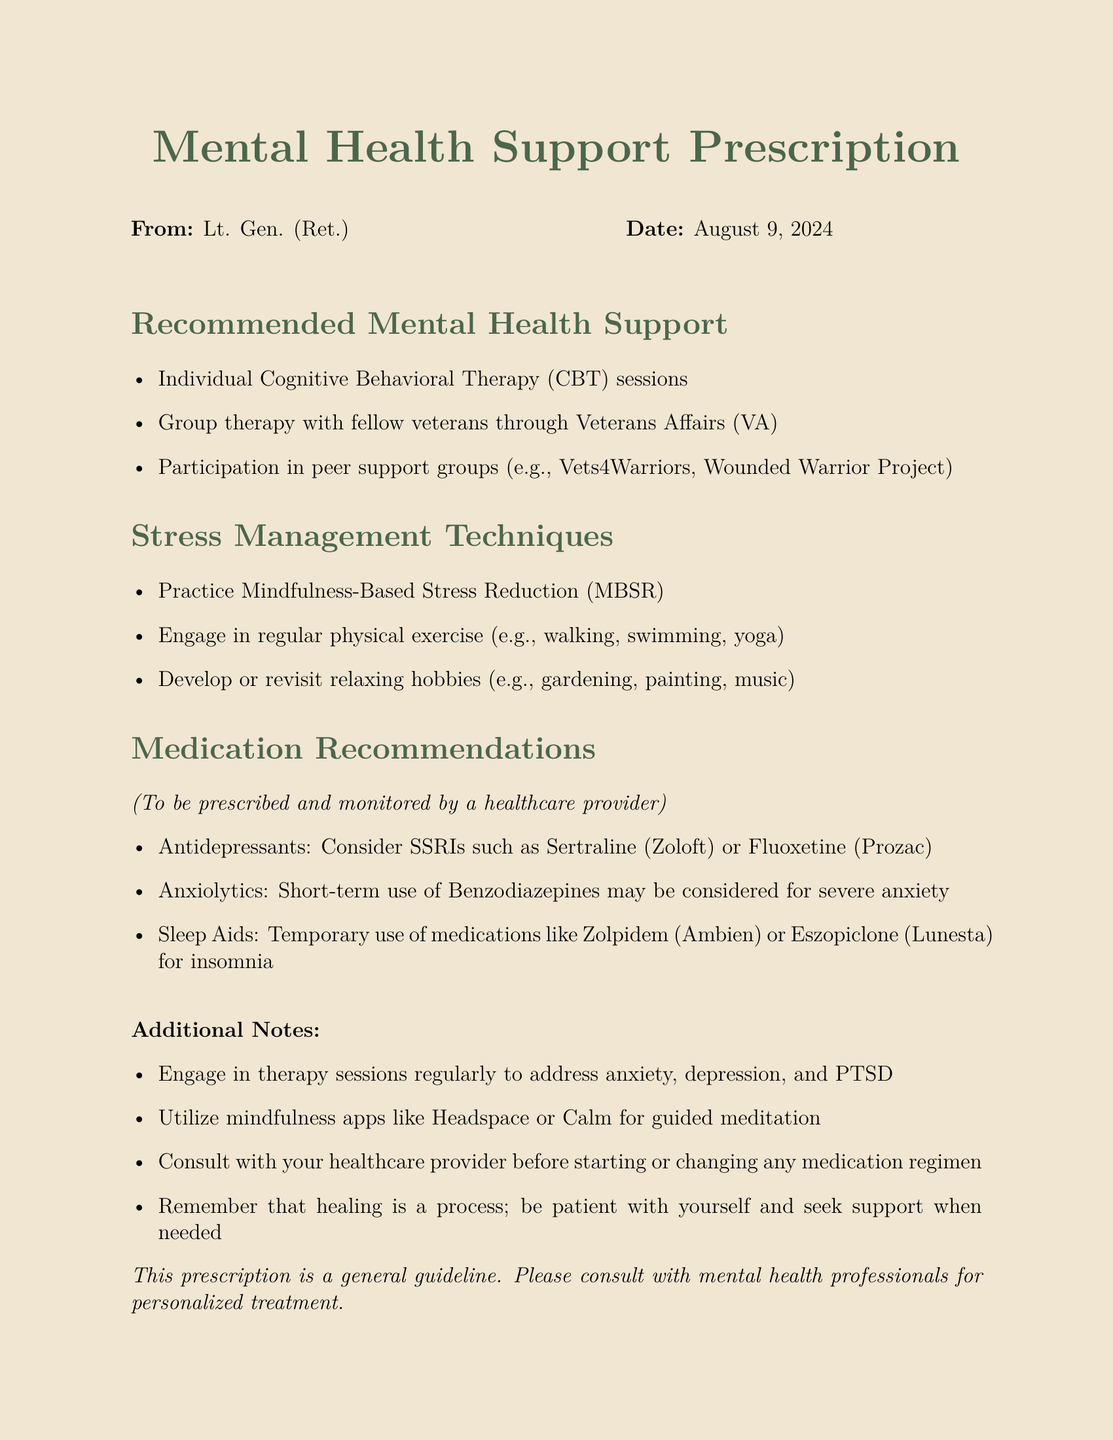What are the recommended individual therapy sessions? The document mentions Cognitive Behavioral Therapy (CBT) sessions as the recommended individual therapy.
Answer: Cognitive Behavioral Therapy (CBT) sessions What is one of the relaxation hobbies suggested? The document lists various relaxing hobbies and one mentioned is gardening.
Answer: gardening Which medications are suggested as antidepressants? The document specifies SSRIs such as Sertraline (Zoloft) or Fluoxetine (Prozac) as antidepressants.
Answer: Sertraline (Zoloft) or Fluoxetine (Prozac) What type of therapy is advised for veterans? The document recommends group therapy with fellow veterans through Veterans Affairs (VA).
Answer: group therapy What mindfulness technique should be practiced? The document recommends practicing Mindfulness-Based Stress Reduction (MBSR) as a technique.
Answer: Mindfulness-Based Stress Reduction (MBSR) Which apps are suggested for mindfulness? The document suggests using mindfulness apps like Headspace or Calm for guided meditation.
Answer: Headspace or Calm What condition do the medications aim to address? The medications mentioned are aimed at conditions like anxiety, depression, and insomnia as specified in the document.
Answer: anxiety, depression, and insomnia How should one approach the use of medications? The document advises to consult with a healthcare provider before starting or changing any medication regimen.
Answer: consult with your healthcare provider What is a key note about the healing process? The document states that healing is a process and emphasizes the importance of patience.
Answer: be patient with yourself 